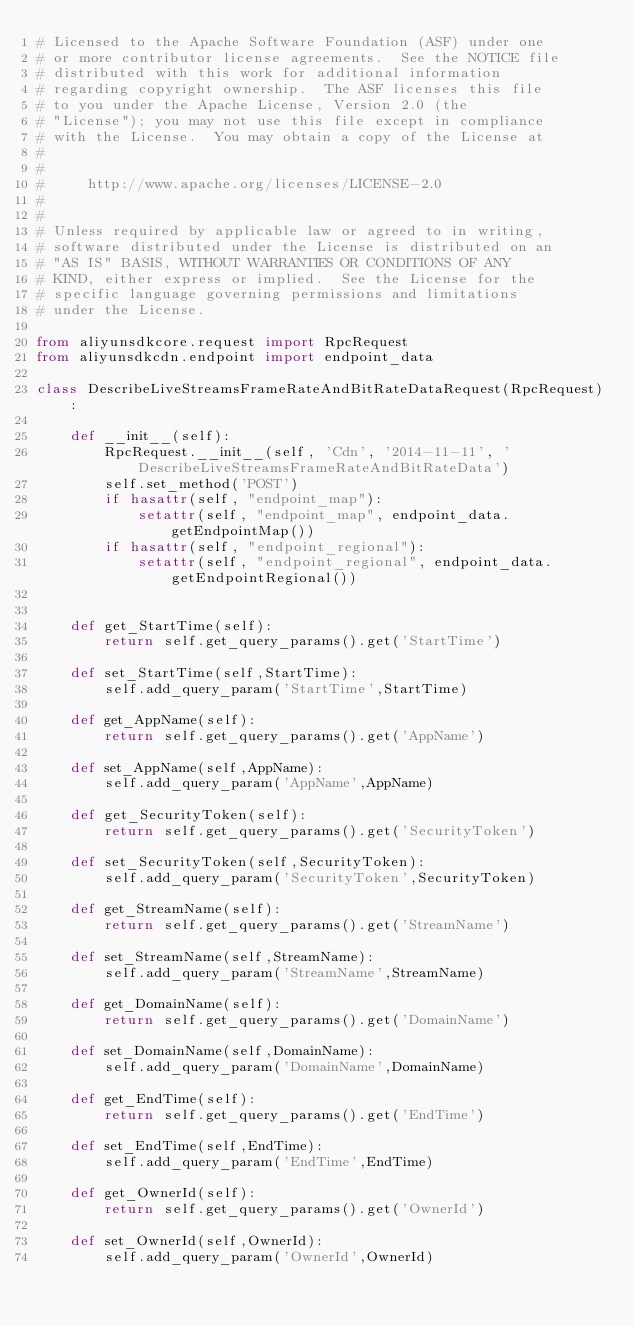Convert code to text. <code><loc_0><loc_0><loc_500><loc_500><_Python_># Licensed to the Apache Software Foundation (ASF) under one
# or more contributor license agreements.  See the NOTICE file
# distributed with this work for additional information
# regarding copyright ownership.  The ASF licenses this file
# to you under the Apache License, Version 2.0 (the
# "License"); you may not use this file except in compliance
# with the License.  You may obtain a copy of the License at
#
#
#     http://www.apache.org/licenses/LICENSE-2.0
#
#
# Unless required by applicable law or agreed to in writing,
# software distributed under the License is distributed on an
# "AS IS" BASIS, WITHOUT WARRANTIES OR CONDITIONS OF ANY
# KIND, either express or implied.  See the License for the
# specific language governing permissions and limitations
# under the License.

from aliyunsdkcore.request import RpcRequest
from aliyunsdkcdn.endpoint import endpoint_data

class DescribeLiveStreamsFrameRateAndBitRateDataRequest(RpcRequest):

	def __init__(self):
		RpcRequest.__init__(self, 'Cdn', '2014-11-11', 'DescribeLiveStreamsFrameRateAndBitRateData')
		self.set_method('POST')
		if hasattr(self, "endpoint_map"):
			setattr(self, "endpoint_map", endpoint_data.getEndpointMap())
		if hasattr(self, "endpoint_regional"):
			setattr(self, "endpoint_regional", endpoint_data.getEndpointRegional())


	def get_StartTime(self):
		return self.get_query_params().get('StartTime')

	def set_StartTime(self,StartTime):
		self.add_query_param('StartTime',StartTime)

	def get_AppName(self):
		return self.get_query_params().get('AppName')

	def set_AppName(self,AppName):
		self.add_query_param('AppName',AppName)

	def get_SecurityToken(self):
		return self.get_query_params().get('SecurityToken')

	def set_SecurityToken(self,SecurityToken):
		self.add_query_param('SecurityToken',SecurityToken)

	def get_StreamName(self):
		return self.get_query_params().get('StreamName')

	def set_StreamName(self,StreamName):
		self.add_query_param('StreamName',StreamName)

	def get_DomainName(self):
		return self.get_query_params().get('DomainName')

	def set_DomainName(self,DomainName):
		self.add_query_param('DomainName',DomainName)

	def get_EndTime(self):
		return self.get_query_params().get('EndTime')

	def set_EndTime(self,EndTime):
		self.add_query_param('EndTime',EndTime)

	def get_OwnerId(self):
		return self.get_query_params().get('OwnerId')

	def set_OwnerId(self,OwnerId):
		self.add_query_param('OwnerId',OwnerId)</code> 